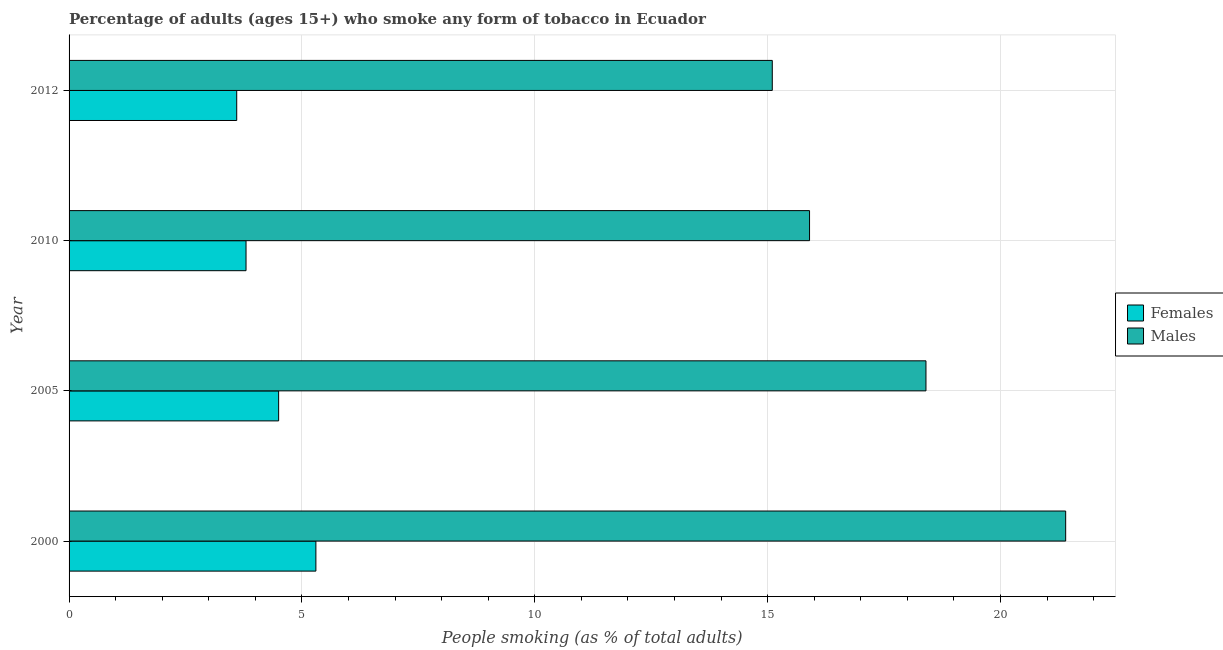How many different coloured bars are there?
Give a very brief answer. 2. How many groups of bars are there?
Keep it short and to the point. 4. Are the number of bars per tick equal to the number of legend labels?
Keep it short and to the point. Yes. Are the number of bars on each tick of the Y-axis equal?
Your response must be concise. Yes. In how many cases, is the number of bars for a given year not equal to the number of legend labels?
Keep it short and to the point. 0. Across all years, what is the maximum percentage of males who smoke?
Provide a short and direct response. 21.4. In which year was the percentage of males who smoke minimum?
Your answer should be compact. 2012. What is the total percentage of females who smoke in the graph?
Your response must be concise. 17.2. What is the difference between the percentage of females who smoke in 2005 and that in 2010?
Provide a short and direct response. 0.7. In the year 2012, what is the difference between the percentage of females who smoke and percentage of males who smoke?
Offer a terse response. -11.5. What is the ratio of the percentage of females who smoke in 2005 to that in 2010?
Your answer should be compact. 1.18. Is the difference between the percentage of females who smoke in 2000 and 2012 greater than the difference between the percentage of males who smoke in 2000 and 2012?
Keep it short and to the point. No. In how many years, is the percentage of males who smoke greater than the average percentage of males who smoke taken over all years?
Your answer should be compact. 2. What does the 2nd bar from the top in 2012 represents?
Your response must be concise. Females. What does the 2nd bar from the bottom in 2005 represents?
Give a very brief answer. Males. How many years are there in the graph?
Your answer should be compact. 4. What is the difference between two consecutive major ticks on the X-axis?
Make the answer very short. 5. Where does the legend appear in the graph?
Offer a terse response. Center right. How are the legend labels stacked?
Provide a succinct answer. Vertical. What is the title of the graph?
Your response must be concise. Percentage of adults (ages 15+) who smoke any form of tobacco in Ecuador. Does "Male entrants" appear as one of the legend labels in the graph?
Offer a very short reply. No. What is the label or title of the X-axis?
Provide a succinct answer. People smoking (as % of total adults). What is the label or title of the Y-axis?
Your answer should be compact. Year. What is the People smoking (as % of total adults) of Males in 2000?
Your answer should be compact. 21.4. What is the People smoking (as % of total adults) in Females in 2005?
Ensure brevity in your answer.  4.5. What is the People smoking (as % of total adults) of Males in 2010?
Provide a short and direct response. 15.9. What is the People smoking (as % of total adults) of Females in 2012?
Ensure brevity in your answer.  3.6. What is the People smoking (as % of total adults) in Males in 2012?
Ensure brevity in your answer.  15.1. Across all years, what is the maximum People smoking (as % of total adults) in Females?
Your response must be concise. 5.3. Across all years, what is the maximum People smoking (as % of total adults) of Males?
Make the answer very short. 21.4. Across all years, what is the minimum People smoking (as % of total adults) of Females?
Make the answer very short. 3.6. What is the total People smoking (as % of total adults) of Males in the graph?
Keep it short and to the point. 70.8. What is the difference between the People smoking (as % of total adults) in Males in 2000 and that in 2010?
Make the answer very short. 5.5. What is the difference between the People smoking (as % of total adults) of Females in 2005 and that in 2010?
Offer a very short reply. 0.7. What is the difference between the People smoking (as % of total adults) in Males in 2005 and that in 2010?
Keep it short and to the point. 2.5. What is the difference between the People smoking (as % of total adults) of Females in 2005 and that in 2012?
Provide a succinct answer. 0.9. What is the difference between the People smoking (as % of total adults) in Males in 2005 and that in 2012?
Your answer should be compact. 3.3. What is the difference between the People smoking (as % of total adults) in Females in 2010 and that in 2012?
Give a very brief answer. 0.2. What is the difference between the People smoking (as % of total adults) in Females in 2000 and the People smoking (as % of total adults) in Males in 2005?
Your answer should be compact. -13.1. What is the difference between the People smoking (as % of total adults) of Females in 2000 and the People smoking (as % of total adults) of Males in 2010?
Make the answer very short. -10.6. What is the difference between the People smoking (as % of total adults) in Females in 2005 and the People smoking (as % of total adults) in Males in 2012?
Give a very brief answer. -10.6. What is the difference between the People smoking (as % of total adults) in Females in 2010 and the People smoking (as % of total adults) in Males in 2012?
Ensure brevity in your answer.  -11.3. What is the average People smoking (as % of total adults) of Females per year?
Offer a very short reply. 4.3. In the year 2000, what is the difference between the People smoking (as % of total adults) in Females and People smoking (as % of total adults) in Males?
Provide a short and direct response. -16.1. In the year 2012, what is the difference between the People smoking (as % of total adults) of Females and People smoking (as % of total adults) of Males?
Your answer should be compact. -11.5. What is the ratio of the People smoking (as % of total adults) in Females in 2000 to that in 2005?
Provide a short and direct response. 1.18. What is the ratio of the People smoking (as % of total adults) in Males in 2000 to that in 2005?
Provide a succinct answer. 1.16. What is the ratio of the People smoking (as % of total adults) in Females in 2000 to that in 2010?
Your response must be concise. 1.39. What is the ratio of the People smoking (as % of total adults) of Males in 2000 to that in 2010?
Keep it short and to the point. 1.35. What is the ratio of the People smoking (as % of total adults) of Females in 2000 to that in 2012?
Offer a terse response. 1.47. What is the ratio of the People smoking (as % of total adults) in Males in 2000 to that in 2012?
Provide a succinct answer. 1.42. What is the ratio of the People smoking (as % of total adults) in Females in 2005 to that in 2010?
Your answer should be compact. 1.18. What is the ratio of the People smoking (as % of total adults) of Males in 2005 to that in 2010?
Provide a short and direct response. 1.16. What is the ratio of the People smoking (as % of total adults) of Males in 2005 to that in 2012?
Offer a very short reply. 1.22. What is the ratio of the People smoking (as % of total adults) of Females in 2010 to that in 2012?
Your answer should be compact. 1.06. What is the ratio of the People smoking (as % of total adults) in Males in 2010 to that in 2012?
Make the answer very short. 1.05. What is the difference between the highest and the second highest People smoking (as % of total adults) of Females?
Your answer should be compact. 0.8. What is the difference between the highest and the lowest People smoking (as % of total adults) of Females?
Your response must be concise. 1.7. 